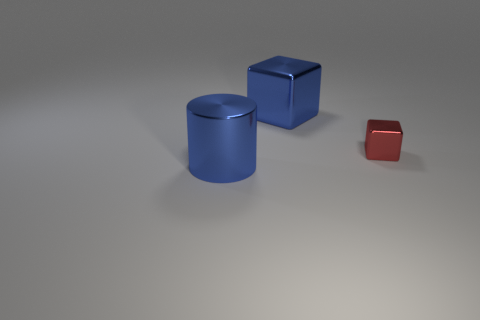Does the blue metal cube have the same size as the red cube?
Ensure brevity in your answer.  No. What shape is the blue object left of the big blue shiny cube?
Provide a short and direct response. Cylinder. There is a cube that is in front of the cube on the left side of the tiny red thing; what color is it?
Make the answer very short. Red. There is a big metal thing that is behind the large blue shiny cylinder; does it have the same shape as the object right of the large cube?
Ensure brevity in your answer.  Yes. The object that is the same size as the blue metallic block is what shape?
Make the answer very short. Cylinder. What color is the block that is made of the same material as the small red thing?
Provide a succinct answer. Blue. Is the shape of the red metal object the same as the blue metallic thing that is behind the blue metallic cylinder?
Your answer should be compact. Yes. Are there any big cylinders that have the same color as the small cube?
Make the answer very short. No. What shape is the thing that is both behind the large cylinder and in front of the blue metal block?
Provide a succinct answer. Cube. What number of small gray objects have the same material as the tiny red object?
Offer a terse response. 0. 